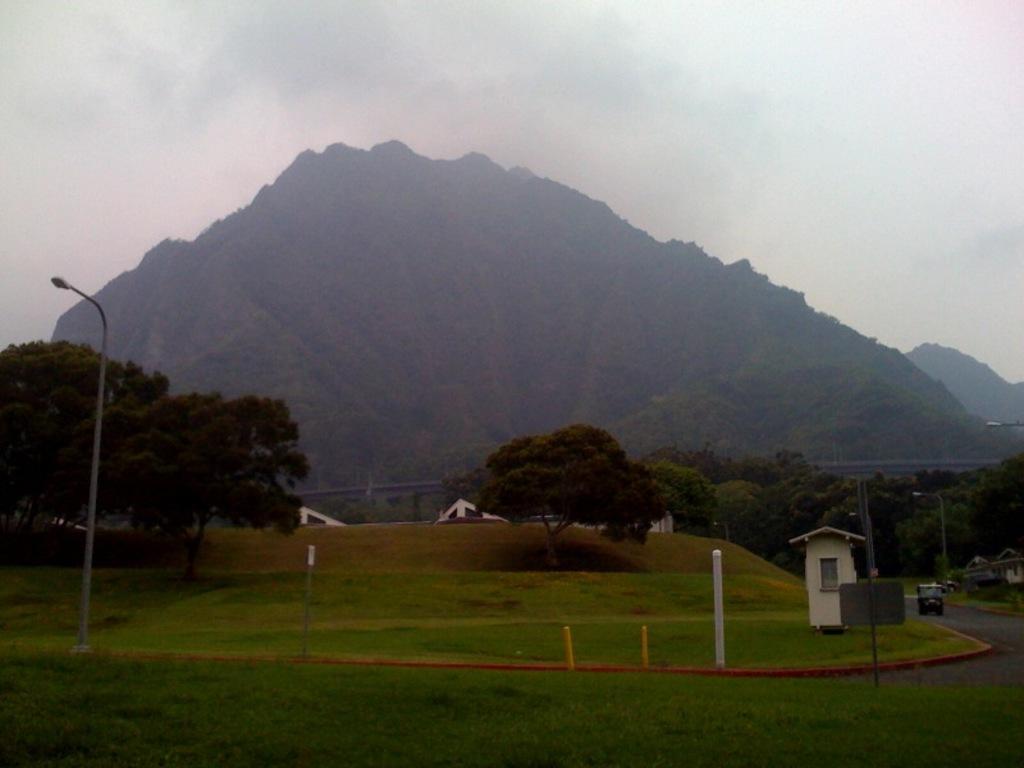Describe this image in one or two sentences. In this image I can see a mountain and trees and a light pole and some buildings in the center of the image and at the bottom of the image I can see garden and a road and a car on the road and there is a check post. 